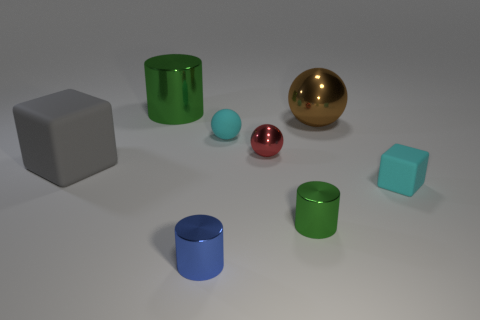Subtract 1 balls. How many balls are left? 2 Subtract all tiny metallic cylinders. How many cylinders are left? 1 Add 2 big brown spheres. How many objects exist? 10 Add 5 large green metallic cylinders. How many large green metallic cylinders are left? 6 Add 1 big brown metal objects. How many big brown metal objects exist? 2 Subtract 0 green cubes. How many objects are left? 8 Subtract all blocks. How many objects are left? 6 Subtract all brown cylinders. Subtract all blue cubes. How many cylinders are left? 3 Subtract all big metallic objects. Subtract all cylinders. How many objects are left? 3 